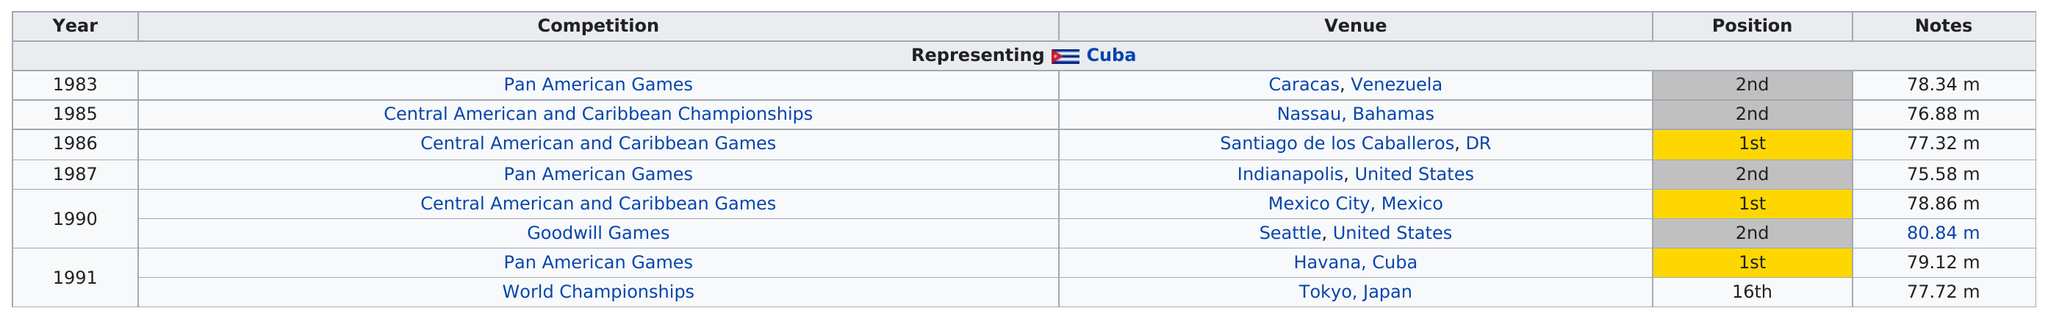Identify some key points in this picture. The higher number of meters listed in the notes section of the table is 80.84 meters. The Pan American Games is the competition that appears the most on the table. In total, there are 8 games listed. Ramon Gonzales has achieved first place in several competitions, including the Central American and Caribbean Games and the Pan American Games. In the 1990 Goodwill Games, he achieved the highest level of competition and proved his excellence in throwing. 